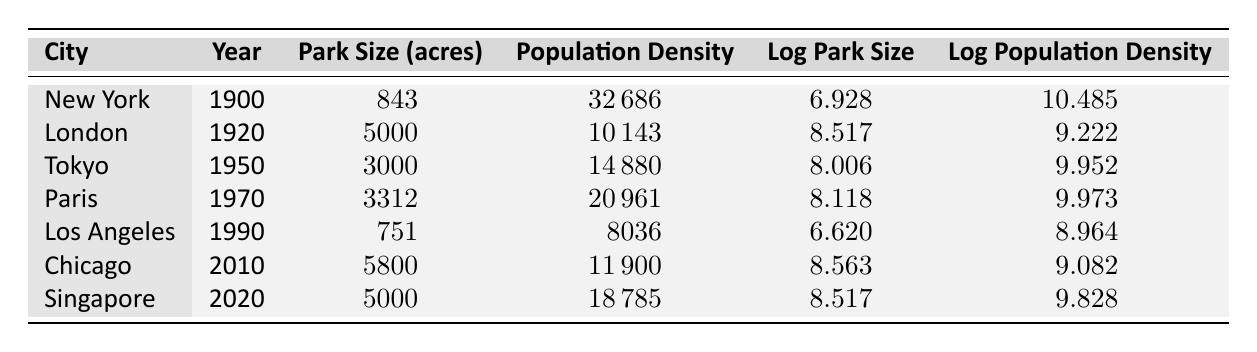What was the park size in New York in 1900? According to the table, the park size in New York in 1900 is listed under the Park Size (acres) column as 843.
Answer: 843 Which city had the highest population density in 1970? From the table, the population density for Paris in 1970 is 20961, while other cities listed for that year are not present. Therefore, Paris has the highest population density in 1970 compared to others.
Answer: Paris What is the difference in park size between Tokyo in 1950 and Los Angeles in 1990? The park size for Tokyo in 1950 is 3000 acres and for Los Angeles in 1990 is 751 acres. The difference is calculated as 3000 - 751 = 2249 acres.
Answer: 2249 Does Singapore's park size in 2020 exceed 4000 acres? Referring to the table, Singapore's park size in 2020 is noted as 5000 acres, which is greater than 4000 acres, confirming the statement is true.
Answer: Yes What is the average park size of the listed cities over the years? Adding the park sizes: (843 + 5000 + 3000 + 3312 + 751 + 5800 + 5000) = 18906 acres. There are 7 cities, so the average is 18906 / 7 = 2708. This yields an average park size of approximately 2708 acres.
Answer: 2708 What can be said about the trend in population density from New York in 1900 compared to Chicago in 2010? The population density in New York in 1900 is 32686, while Chicago in 2010 has a population density of 11900. The density has decreased significantly from 1900 to 2010 when comparing these two cities.
Answer: Decreased significantly Is the park size in London in 1920 greater than the combined park sizes of New York in 1900 and Los Angeles in 1990? The park size in London in 1920 is 5000 acres. The combined park sizes of New York (843 acres) and Los Angeles (751 acres) are 843 + 751 = 1594 acres. Since 5000 is greater than 1594, the answer is yes.
Answer: Yes How has the park size changed from Paris in 1970 to Chicago in 2010? The park size in Paris in 1970 is 3312 acres, and in Chicago in 2010 it is 5800 acres. To find the change, we take 5800 - 3312 = 2488 acres, indicating an increase in park size from Paris to Chicago.
Answer: Increased by 2488 acres 